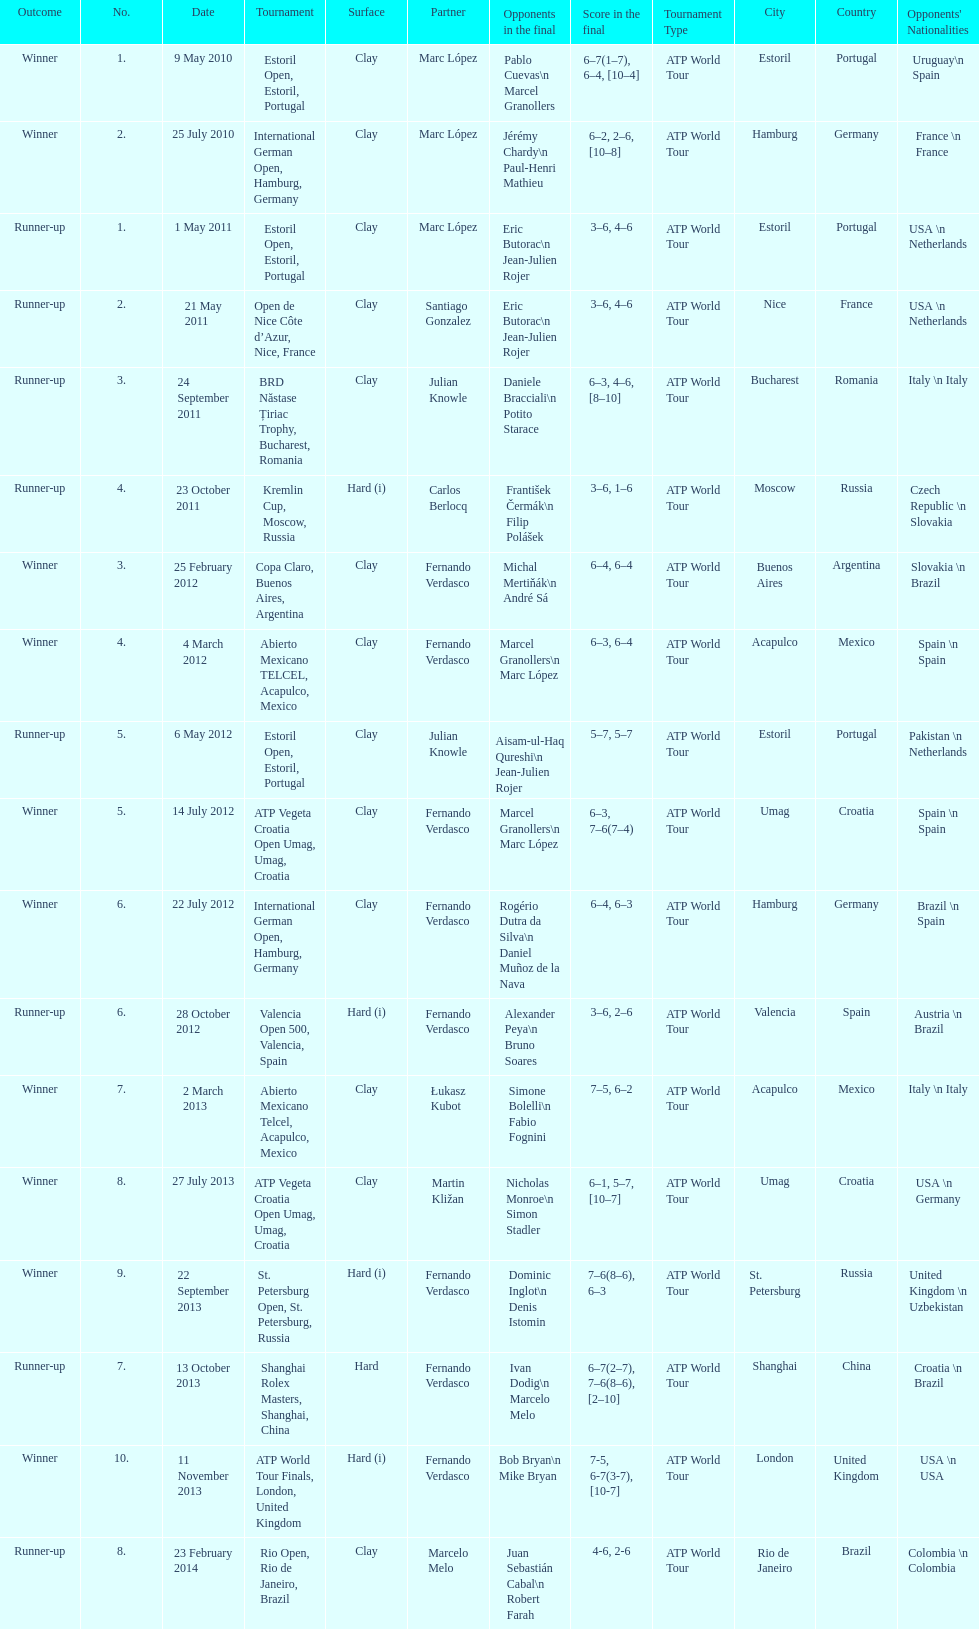Which tournament has the largest number? ATP World Tour Finals. 